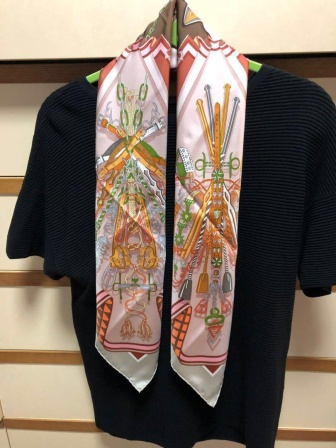Can you tell me a story about the person who owns these items? Certainly! Once upon a time, there was a creative individual named Alex who had a keen eye for fashion and an appreciation for the finer details in life. Alex loved to explore quaint little shops and vintage boutiques, collecting unique items that spoke to their artistic soul. The black sweater, with its soft texture, was a comforting piece Alex wore during chilly evenings while sipping tea and reading poetry. The scarf, a vivid explosion of colors and patterns, was a special find during a trip to a bustling market in a distant town. Each object on the scarf had a story – the teapot reminded Alex of cozy tea sessions with friends, the vase of their love for fresh flowers, and the basket of their adventures in nature. Alex cherished these items, not just for their aesthetic appeal, but for the warmth and memories they carried. 